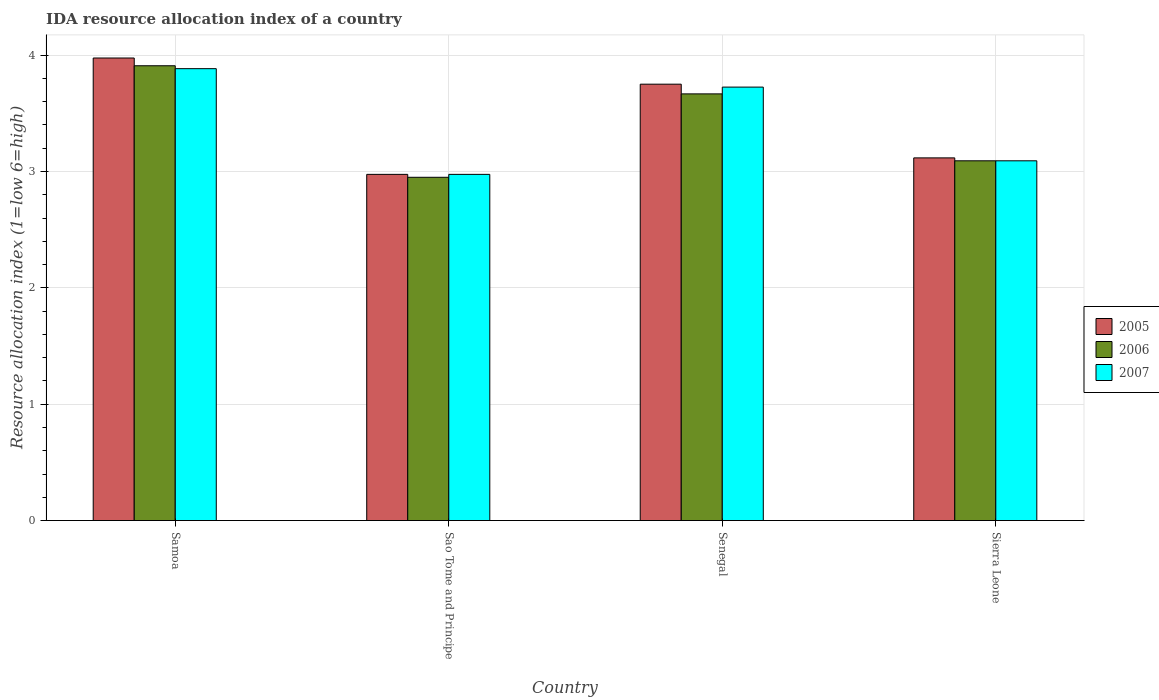How many groups of bars are there?
Give a very brief answer. 4. Are the number of bars per tick equal to the number of legend labels?
Your answer should be compact. Yes. Are the number of bars on each tick of the X-axis equal?
Your answer should be compact. Yes. What is the label of the 4th group of bars from the left?
Make the answer very short. Sierra Leone. In how many cases, is the number of bars for a given country not equal to the number of legend labels?
Your answer should be compact. 0. What is the IDA resource allocation index in 2007 in Samoa?
Ensure brevity in your answer.  3.88. Across all countries, what is the maximum IDA resource allocation index in 2006?
Your answer should be compact. 3.91. Across all countries, what is the minimum IDA resource allocation index in 2005?
Your response must be concise. 2.98. In which country was the IDA resource allocation index in 2005 maximum?
Ensure brevity in your answer.  Samoa. In which country was the IDA resource allocation index in 2006 minimum?
Your answer should be very brief. Sao Tome and Principe. What is the total IDA resource allocation index in 2007 in the graph?
Keep it short and to the point. 13.68. What is the difference between the IDA resource allocation index in 2006 in Samoa and that in Sao Tome and Principe?
Provide a short and direct response. 0.96. What is the difference between the IDA resource allocation index in 2006 in Samoa and the IDA resource allocation index in 2005 in Senegal?
Your answer should be compact. 0.16. What is the average IDA resource allocation index in 2007 per country?
Give a very brief answer. 3.42. What is the difference between the IDA resource allocation index of/in 2005 and IDA resource allocation index of/in 2006 in Samoa?
Offer a terse response. 0.07. In how many countries, is the IDA resource allocation index in 2006 greater than 1.4?
Your response must be concise. 4. What is the ratio of the IDA resource allocation index in 2005 in Samoa to that in Sao Tome and Principe?
Your response must be concise. 1.34. Is the difference between the IDA resource allocation index in 2005 in Sao Tome and Principe and Senegal greater than the difference between the IDA resource allocation index in 2006 in Sao Tome and Principe and Senegal?
Make the answer very short. No. What is the difference between the highest and the second highest IDA resource allocation index in 2006?
Offer a very short reply. -0.24. What is the difference between the highest and the lowest IDA resource allocation index in 2006?
Ensure brevity in your answer.  0.96. In how many countries, is the IDA resource allocation index in 2005 greater than the average IDA resource allocation index in 2005 taken over all countries?
Offer a very short reply. 2. Is the sum of the IDA resource allocation index in 2005 in Samoa and Sao Tome and Principe greater than the maximum IDA resource allocation index in 2006 across all countries?
Ensure brevity in your answer.  Yes. What does the 2nd bar from the right in Samoa represents?
Offer a very short reply. 2006. Are all the bars in the graph horizontal?
Offer a terse response. No. How many countries are there in the graph?
Your response must be concise. 4. Are the values on the major ticks of Y-axis written in scientific E-notation?
Give a very brief answer. No. Does the graph contain any zero values?
Offer a terse response. No. How many legend labels are there?
Offer a terse response. 3. How are the legend labels stacked?
Give a very brief answer. Vertical. What is the title of the graph?
Your answer should be very brief. IDA resource allocation index of a country. Does "2001" appear as one of the legend labels in the graph?
Your response must be concise. No. What is the label or title of the X-axis?
Keep it short and to the point. Country. What is the label or title of the Y-axis?
Your answer should be very brief. Resource allocation index (1=low 6=high). What is the Resource allocation index (1=low 6=high) of 2005 in Samoa?
Offer a very short reply. 3.98. What is the Resource allocation index (1=low 6=high) in 2006 in Samoa?
Ensure brevity in your answer.  3.91. What is the Resource allocation index (1=low 6=high) in 2007 in Samoa?
Offer a terse response. 3.88. What is the Resource allocation index (1=low 6=high) in 2005 in Sao Tome and Principe?
Your response must be concise. 2.98. What is the Resource allocation index (1=low 6=high) of 2006 in Sao Tome and Principe?
Your answer should be compact. 2.95. What is the Resource allocation index (1=low 6=high) in 2007 in Sao Tome and Principe?
Offer a very short reply. 2.98. What is the Resource allocation index (1=low 6=high) in 2005 in Senegal?
Offer a very short reply. 3.75. What is the Resource allocation index (1=low 6=high) in 2006 in Senegal?
Your answer should be compact. 3.67. What is the Resource allocation index (1=low 6=high) in 2007 in Senegal?
Provide a short and direct response. 3.73. What is the Resource allocation index (1=low 6=high) of 2005 in Sierra Leone?
Make the answer very short. 3.12. What is the Resource allocation index (1=low 6=high) of 2006 in Sierra Leone?
Provide a short and direct response. 3.09. What is the Resource allocation index (1=low 6=high) in 2007 in Sierra Leone?
Provide a succinct answer. 3.09. Across all countries, what is the maximum Resource allocation index (1=low 6=high) in 2005?
Offer a terse response. 3.98. Across all countries, what is the maximum Resource allocation index (1=low 6=high) in 2006?
Your answer should be very brief. 3.91. Across all countries, what is the maximum Resource allocation index (1=low 6=high) of 2007?
Your answer should be very brief. 3.88. Across all countries, what is the minimum Resource allocation index (1=low 6=high) in 2005?
Give a very brief answer. 2.98. Across all countries, what is the minimum Resource allocation index (1=low 6=high) of 2006?
Your response must be concise. 2.95. Across all countries, what is the minimum Resource allocation index (1=low 6=high) in 2007?
Provide a short and direct response. 2.98. What is the total Resource allocation index (1=low 6=high) in 2005 in the graph?
Your answer should be compact. 13.82. What is the total Resource allocation index (1=low 6=high) of 2006 in the graph?
Offer a very short reply. 13.62. What is the total Resource allocation index (1=low 6=high) of 2007 in the graph?
Offer a very short reply. 13.68. What is the difference between the Resource allocation index (1=low 6=high) of 2005 in Samoa and that in Sao Tome and Principe?
Your answer should be very brief. 1. What is the difference between the Resource allocation index (1=low 6=high) of 2006 in Samoa and that in Sao Tome and Principe?
Your answer should be compact. 0.96. What is the difference between the Resource allocation index (1=low 6=high) of 2007 in Samoa and that in Sao Tome and Principe?
Offer a terse response. 0.91. What is the difference between the Resource allocation index (1=low 6=high) of 2005 in Samoa and that in Senegal?
Offer a very short reply. 0.23. What is the difference between the Resource allocation index (1=low 6=high) in 2006 in Samoa and that in Senegal?
Provide a short and direct response. 0.24. What is the difference between the Resource allocation index (1=low 6=high) of 2007 in Samoa and that in Senegal?
Offer a very short reply. 0.16. What is the difference between the Resource allocation index (1=low 6=high) of 2005 in Samoa and that in Sierra Leone?
Give a very brief answer. 0.86. What is the difference between the Resource allocation index (1=low 6=high) in 2006 in Samoa and that in Sierra Leone?
Your answer should be very brief. 0.82. What is the difference between the Resource allocation index (1=low 6=high) in 2007 in Samoa and that in Sierra Leone?
Provide a succinct answer. 0.79. What is the difference between the Resource allocation index (1=low 6=high) in 2005 in Sao Tome and Principe and that in Senegal?
Provide a succinct answer. -0.78. What is the difference between the Resource allocation index (1=low 6=high) in 2006 in Sao Tome and Principe and that in Senegal?
Provide a succinct answer. -0.72. What is the difference between the Resource allocation index (1=low 6=high) in 2007 in Sao Tome and Principe and that in Senegal?
Offer a terse response. -0.75. What is the difference between the Resource allocation index (1=low 6=high) in 2005 in Sao Tome and Principe and that in Sierra Leone?
Your response must be concise. -0.14. What is the difference between the Resource allocation index (1=low 6=high) of 2006 in Sao Tome and Principe and that in Sierra Leone?
Your answer should be compact. -0.14. What is the difference between the Resource allocation index (1=low 6=high) in 2007 in Sao Tome and Principe and that in Sierra Leone?
Make the answer very short. -0.12. What is the difference between the Resource allocation index (1=low 6=high) in 2005 in Senegal and that in Sierra Leone?
Make the answer very short. 0.63. What is the difference between the Resource allocation index (1=low 6=high) in 2006 in Senegal and that in Sierra Leone?
Offer a terse response. 0.57. What is the difference between the Resource allocation index (1=low 6=high) of 2007 in Senegal and that in Sierra Leone?
Provide a short and direct response. 0.63. What is the difference between the Resource allocation index (1=low 6=high) of 2005 in Samoa and the Resource allocation index (1=low 6=high) of 2006 in Sao Tome and Principe?
Provide a short and direct response. 1.02. What is the difference between the Resource allocation index (1=low 6=high) of 2005 in Samoa and the Resource allocation index (1=low 6=high) of 2007 in Sao Tome and Principe?
Keep it short and to the point. 1. What is the difference between the Resource allocation index (1=low 6=high) of 2005 in Samoa and the Resource allocation index (1=low 6=high) of 2006 in Senegal?
Give a very brief answer. 0.31. What is the difference between the Resource allocation index (1=low 6=high) in 2005 in Samoa and the Resource allocation index (1=low 6=high) in 2007 in Senegal?
Give a very brief answer. 0.25. What is the difference between the Resource allocation index (1=low 6=high) of 2006 in Samoa and the Resource allocation index (1=low 6=high) of 2007 in Senegal?
Give a very brief answer. 0.18. What is the difference between the Resource allocation index (1=low 6=high) in 2005 in Samoa and the Resource allocation index (1=low 6=high) in 2006 in Sierra Leone?
Keep it short and to the point. 0.88. What is the difference between the Resource allocation index (1=low 6=high) in 2005 in Samoa and the Resource allocation index (1=low 6=high) in 2007 in Sierra Leone?
Offer a terse response. 0.88. What is the difference between the Resource allocation index (1=low 6=high) of 2006 in Samoa and the Resource allocation index (1=low 6=high) of 2007 in Sierra Leone?
Your answer should be compact. 0.82. What is the difference between the Resource allocation index (1=low 6=high) in 2005 in Sao Tome and Principe and the Resource allocation index (1=low 6=high) in 2006 in Senegal?
Your answer should be compact. -0.69. What is the difference between the Resource allocation index (1=low 6=high) of 2005 in Sao Tome and Principe and the Resource allocation index (1=low 6=high) of 2007 in Senegal?
Your response must be concise. -0.75. What is the difference between the Resource allocation index (1=low 6=high) of 2006 in Sao Tome and Principe and the Resource allocation index (1=low 6=high) of 2007 in Senegal?
Ensure brevity in your answer.  -0.78. What is the difference between the Resource allocation index (1=low 6=high) of 2005 in Sao Tome and Principe and the Resource allocation index (1=low 6=high) of 2006 in Sierra Leone?
Your answer should be compact. -0.12. What is the difference between the Resource allocation index (1=low 6=high) in 2005 in Sao Tome and Principe and the Resource allocation index (1=low 6=high) in 2007 in Sierra Leone?
Your response must be concise. -0.12. What is the difference between the Resource allocation index (1=low 6=high) in 2006 in Sao Tome and Principe and the Resource allocation index (1=low 6=high) in 2007 in Sierra Leone?
Keep it short and to the point. -0.14. What is the difference between the Resource allocation index (1=low 6=high) of 2005 in Senegal and the Resource allocation index (1=low 6=high) of 2006 in Sierra Leone?
Your response must be concise. 0.66. What is the difference between the Resource allocation index (1=low 6=high) in 2005 in Senegal and the Resource allocation index (1=low 6=high) in 2007 in Sierra Leone?
Ensure brevity in your answer.  0.66. What is the difference between the Resource allocation index (1=low 6=high) in 2006 in Senegal and the Resource allocation index (1=low 6=high) in 2007 in Sierra Leone?
Your response must be concise. 0.57. What is the average Resource allocation index (1=low 6=high) of 2005 per country?
Offer a terse response. 3.45. What is the average Resource allocation index (1=low 6=high) in 2006 per country?
Keep it short and to the point. 3.4. What is the average Resource allocation index (1=low 6=high) in 2007 per country?
Make the answer very short. 3.42. What is the difference between the Resource allocation index (1=low 6=high) in 2005 and Resource allocation index (1=low 6=high) in 2006 in Samoa?
Provide a short and direct response. 0.07. What is the difference between the Resource allocation index (1=low 6=high) of 2005 and Resource allocation index (1=low 6=high) of 2007 in Samoa?
Keep it short and to the point. 0.09. What is the difference between the Resource allocation index (1=low 6=high) in 2006 and Resource allocation index (1=low 6=high) in 2007 in Samoa?
Provide a succinct answer. 0.03. What is the difference between the Resource allocation index (1=low 6=high) in 2005 and Resource allocation index (1=low 6=high) in 2006 in Sao Tome and Principe?
Your response must be concise. 0.03. What is the difference between the Resource allocation index (1=low 6=high) in 2005 and Resource allocation index (1=low 6=high) in 2007 in Sao Tome and Principe?
Offer a very short reply. 0. What is the difference between the Resource allocation index (1=low 6=high) of 2006 and Resource allocation index (1=low 6=high) of 2007 in Sao Tome and Principe?
Your answer should be compact. -0.03. What is the difference between the Resource allocation index (1=low 6=high) in 2005 and Resource allocation index (1=low 6=high) in 2006 in Senegal?
Your answer should be compact. 0.08. What is the difference between the Resource allocation index (1=low 6=high) in 2005 and Resource allocation index (1=low 6=high) in 2007 in Senegal?
Offer a terse response. 0.03. What is the difference between the Resource allocation index (1=low 6=high) in 2006 and Resource allocation index (1=low 6=high) in 2007 in Senegal?
Your answer should be very brief. -0.06. What is the difference between the Resource allocation index (1=low 6=high) in 2005 and Resource allocation index (1=low 6=high) in 2006 in Sierra Leone?
Your answer should be very brief. 0.03. What is the difference between the Resource allocation index (1=low 6=high) in 2005 and Resource allocation index (1=low 6=high) in 2007 in Sierra Leone?
Provide a succinct answer. 0.03. What is the difference between the Resource allocation index (1=low 6=high) in 2006 and Resource allocation index (1=low 6=high) in 2007 in Sierra Leone?
Ensure brevity in your answer.  0. What is the ratio of the Resource allocation index (1=low 6=high) of 2005 in Samoa to that in Sao Tome and Principe?
Provide a short and direct response. 1.34. What is the ratio of the Resource allocation index (1=low 6=high) of 2006 in Samoa to that in Sao Tome and Principe?
Make the answer very short. 1.32. What is the ratio of the Resource allocation index (1=low 6=high) of 2007 in Samoa to that in Sao Tome and Principe?
Your response must be concise. 1.31. What is the ratio of the Resource allocation index (1=low 6=high) of 2005 in Samoa to that in Senegal?
Ensure brevity in your answer.  1.06. What is the ratio of the Resource allocation index (1=low 6=high) in 2006 in Samoa to that in Senegal?
Give a very brief answer. 1.07. What is the ratio of the Resource allocation index (1=low 6=high) of 2007 in Samoa to that in Senegal?
Provide a short and direct response. 1.04. What is the ratio of the Resource allocation index (1=low 6=high) in 2005 in Samoa to that in Sierra Leone?
Ensure brevity in your answer.  1.28. What is the ratio of the Resource allocation index (1=low 6=high) of 2006 in Samoa to that in Sierra Leone?
Give a very brief answer. 1.26. What is the ratio of the Resource allocation index (1=low 6=high) in 2007 in Samoa to that in Sierra Leone?
Provide a succinct answer. 1.26. What is the ratio of the Resource allocation index (1=low 6=high) in 2005 in Sao Tome and Principe to that in Senegal?
Provide a short and direct response. 0.79. What is the ratio of the Resource allocation index (1=low 6=high) in 2006 in Sao Tome and Principe to that in Senegal?
Your response must be concise. 0.8. What is the ratio of the Resource allocation index (1=low 6=high) of 2007 in Sao Tome and Principe to that in Senegal?
Make the answer very short. 0.8. What is the ratio of the Resource allocation index (1=low 6=high) of 2005 in Sao Tome and Principe to that in Sierra Leone?
Your answer should be compact. 0.95. What is the ratio of the Resource allocation index (1=low 6=high) of 2006 in Sao Tome and Principe to that in Sierra Leone?
Provide a short and direct response. 0.95. What is the ratio of the Resource allocation index (1=low 6=high) in 2007 in Sao Tome and Principe to that in Sierra Leone?
Give a very brief answer. 0.96. What is the ratio of the Resource allocation index (1=low 6=high) of 2005 in Senegal to that in Sierra Leone?
Ensure brevity in your answer.  1.2. What is the ratio of the Resource allocation index (1=low 6=high) of 2006 in Senegal to that in Sierra Leone?
Give a very brief answer. 1.19. What is the ratio of the Resource allocation index (1=low 6=high) in 2007 in Senegal to that in Sierra Leone?
Keep it short and to the point. 1.2. What is the difference between the highest and the second highest Resource allocation index (1=low 6=high) of 2005?
Offer a terse response. 0.23. What is the difference between the highest and the second highest Resource allocation index (1=low 6=high) in 2006?
Make the answer very short. 0.24. What is the difference between the highest and the second highest Resource allocation index (1=low 6=high) in 2007?
Make the answer very short. 0.16. What is the difference between the highest and the lowest Resource allocation index (1=low 6=high) of 2007?
Your response must be concise. 0.91. 